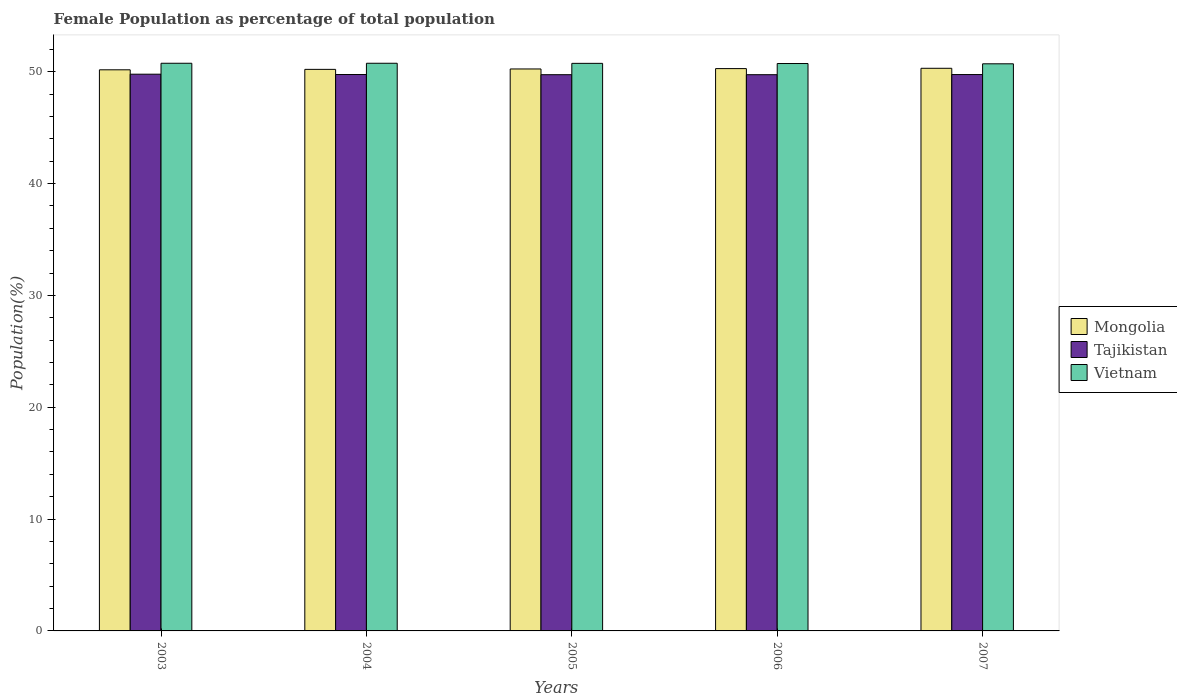How many different coloured bars are there?
Your response must be concise. 3. Are the number of bars on each tick of the X-axis equal?
Offer a terse response. Yes. How many bars are there on the 4th tick from the right?
Provide a short and direct response. 3. What is the label of the 4th group of bars from the left?
Offer a very short reply. 2006. What is the female population in in Vietnam in 2006?
Keep it short and to the point. 50.73. Across all years, what is the maximum female population in in Mongolia?
Ensure brevity in your answer.  50.31. Across all years, what is the minimum female population in in Tajikistan?
Offer a very short reply. 49.74. In which year was the female population in in Vietnam minimum?
Your answer should be compact. 2007. What is the total female population in in Vietnam in the graph?
Provide a short and direct response. 253.71. What is the difference between the female population in in Mongolia in 2004 and that in 2006?
Provide a short and direct response. -0.07. What is the difference between the female population in in Vietnam in 2003 and the female population in in Tajikistan in 2006?
Ensure brevity in your answer.  1.02. What is the average female population in in Mongolia per year?
Your response must be concise. 50.24. In the year 2003, what is the difference between the female population in in Tajikistan and female population in in Mongolia?
Keep it short and to the point. -0.39. What is the ratio of the female population in in Mongolia in 2005 to that in 2006?
Provide a succinct answer. 1. Is the difference between the female population in in Tajikistan in 2004 and 2005 greater than the difference between the female population in in Mongolia in 2004 and 2005?
Offer a terse response. Yes. What is the difference between the highest and the second highest female population in in Vietnam?
Provide a succinct answer. 0. What is the difference between the highest and the lowest female population in in Mongolia?
Your response must be concise. 0.14. Is the sum of the female population in in Tajikistan in 2003 and 2007 greater than the maximum female population in in Mongolia across all years?
Make the answer very short. Yes. What does the 2nd bar from the left in 2005 represents?
Your answer should be very brief. Tajikistan. What does the 2nd bar from the right in 2005 represents?
Offer a terse response. Tajikistan. What is the difference between two consecutive major ticks on the Y-axis?
Your response must be concise. 10. Does the graph contain any zero values?
Offer a terse response. No. Where does the legend appear in the graph?
Your answer should be very brief. Center right. How many legend labels are there?
Your answer should be compact. 3. How are the legend labels stacked?
Ensure brevity in your answer.  Vertical. What is the title of the graph?
Your answer should be compact. Female Population as percentage of total population. What is the label or title of the Y-axis?
Keep it short and to the point. Population(%). What is the Population(%) in Mongolia in 2003?
Offer a very short reply. 50.17. What is the Population(%) in Tajikistan in 2003?
Your response must be concise. 49.78. What is the Population(%) in Vietnam in 2003?
Keep it short and to the point. 50.76. What is the Population(%) of Mongolia in 2004?
Your answer should be compact. 50.21. What is the Population(%) in Tajikistan in 2004?
Provide a succinct answer. 49.75. What is the Population(%) in Vietnam in 2004?
Give a very brief answer. 50.76. What is the Population(%) in Mongolia in 2005?
Keep it short and to the point. 50.25. What is the Population(%) in Tajikistan in 2005?
Give a very brief answer. 49.74. What is the Population(%) in Vietnam in 2005?
Provide a succinct answer. 50.75. What is the Population(%) in Mongolia in 2006?
Keep it short and to the point. 50.28. What is the Population(%) in Tajikistan in 2006?
Provide a succinct answer. 49.74. What is the Population(%) of Vietnam in 2006?
Give a very brief answer. 50.73. What is the Population(%) in Mongolia in 2007?
Your answer should be compact. 50.31. What is the Population(%) in Tajikistan in 2007?
Your answer should be compact. 49.75. What is the Population(%) in Vietnam in 2007?
Give a very brief answer. 50.71. Across all years, what is the maximum Population(%) in Mongolia?
Keep it short and to the point. 50.31. Across all years, what is the maximum Population(%) of Tajikistan?
Ensure brevity in your answer.  49.78. Across all years, what is the maximum Population(%) of Vietnam?
Your response must be concise. 50.76. Across all years, what is the minimum Population(%) in Mongolia?
Your answer should be very brief. 50.17. Across all years, what is the minimum Population(%) in Tajikistan?
Your answer should be compact. 49.74. Across all years, what is the minimum Population(%) in Vietnam?
Keep it short and to the point. 50.71. What is the total Population(%) in Mongolia in the graph?
Offer a very short reply. 251.22. What is the total Population(%) in Tajikistan in the graph?
Your answer should be very brief. 248.75. What is the total Population(%) in Vietnam in the graph?
Make the answer very short. 253.71. What is the difference between the Population(%) of Mongolia in 2003 and that in 2004?
Offer a terse response. -0.04. What is the difference between the Population(%) of Tajikistan in 2003 and that in 2004?
Ensure brevity in your answer.  0.03. What is the difference between the Population(%) of Vietnam in 2003 and that in 2004?
Your answer should be very brief. -0. What is the difference between the Population(%) of Mongolia in 2003 and that in 2005?
Offer a very short reply. -0.08. What is the difference between the Population(%) in Tajikistan in 2003 and that in 2005?
Your answer should be compact. 0.04. What is the difference between the Population(%) of Vietnam in 2003 and that in 2005?
Offer a very short reply. 0.01. What is the difference between the Population(%) in Mongolia in 2003 and that in 2006?
Your answer should be compact. -0.11. What is the difference between the Population(%) in Tajikistan in 2003 and that in 2006?
Give a very brief answer. 0.04. What is the difference between the Population(%) of Vietnam in 2003 and that in 2006?
Your answer should be very brief. 0.02. What is the difference between the Population(%) of Mongolia in 2003 and that in 2007?
Offer a very short reply. -0.14. What is the difference between the Population(%) in Tajikistan in 2003 and that in 2007?
Ensure brevity in your answer.  0.03. What is the difference between the Population(%) of Vietnam in 2003 and that in 2007?
Make the answer very short. 0.05. What is the difference between the Population(%) of Mongolia in 2004 and that in 2005?
Offer a terse response. -0.04. What is the difference between the Population(%) in Tajikistan in 2004 and that in 2005?
Your answer should be very brief. 0.02. What is the difference between the Population(%) of Vietnam in 2004 and that in 2005?
Your response must be concise. 0.01. What is the difference between the Population(%) in Mongolia in 2004 and that in 2006?
Your answer should be compact. -0.07. What is the difference between the Population(%) in Tajikistan in 2004 and that in 2006?
Your answer should be very brief. 0.02. What is the difference between the Population(%) in Vietnam in 2004 and that in 2006?
Offer a very short reply. 0.02. What is the difference between the Population(%) of Mongolia in 2004 and that in 2007?
Your answer should be compact. -0.1. What is the difference between the Population(%) of Tajikistan in 2004 and that in 2007?
Keep it short and to the point. 0. What is the difference between the Population(%) of Vietnam in 2004 and that in 2007?
Provide a succinct answer. 0.05. What is the difference between the Population(%) of Mongolia in 2005 and that in 2006?
Your response must be concise. -0.03. What is the difference between the Population(%) in Tajikistan in 2005 and that in 2006?
Keep it short and to the point. -0. What is the difference between the Population(%) of Vietnam in 2005 and that in 2006?
Make the answer very short. 0.02. What is the difference between the Population(%) of Mongolia in 2005 and that in 2007?
Your answer should be very brief. -0.06. What is the difference between the Population(%) of Tajikistan in 2005 and that in 2007?
Your answer should be very brief. -0.01. What is the difference between the Population(%) in Vietnam in 2005 and that in 2007?
Your answer should be very brief. 0.04. What is the difference between the Population(%) of Mongolia in 2006 and that in 2007?
Make the answer very short. -0.03. What is the difference between the Population(%) in Tajikistan in 2006 and that in 2007?
Offer a very short reply. -0.01. What is the difference between the Population(%) of Vietnam in 2006 and that in 2007?
Make the answer very short. 0.02. What is the difference between the Population(%) in Mongolia in 2003 and the Population(%) in Tajikistan in 2004?
Your response must be concise. 0.42. What is the difference between the Population(%) of Mongolia in 2003 and the Population(%) of Vietnam in 2004?
Your answer should be very brief. -0.59. What is the difference between the Population(%) of Tajikistan in 2003 and the Population(%) of Vietnam in 2004?
Keep it short and to the point. -0.98. What is the difference between the Population(%) in Mongolia in 2003 and the Population(%) in Tajikistan in 2005?
Keep it short and to the point. 0.44. What is the difference between the Population(%) of Mongolia in 2003 and the Population(%) of Vietnam in 2005?
Offer a very short reply. -0.58. What is the difference between the Population(%) of Tajikistan in 2003 and the Population(%) of Vietnam in 2005?
Provide a short and direct response. -0.97. What is the difference between the Population(%) of Mongolia in 2003 and the Population(%) of Tajikistan in 2006?
Your answer should be compact. 0.44. What is the difference between the Population(%) in Mongolia in 2003 and the Population(%) in Vietnam in 2006?
Provide a succinct answer. -0.56. What is the difference between the Population(%) in Tajikistan in 2003 and the Population(%) in Vietnam in 2006?
Provide a succinct answer. -0.95. What is the difference between the Population(%) in Mongolia in 2003 and the Population(%) in Tajikistan in 2007?
Provide a succinct answer. 0.42. What is the difference between the Population(%) of Mongolia in 2003 and the Population(%) of Vietnam in 2007?
Make the answer very short. -0.54. What is the difference between the Population(%) in Tajikistan in 2003 and the Population(%) in Vietnam in 2007?
Give a very brief answer. -0.93. What is the difference between the Population(%) in Mongolia in 2004 and the Population(%) in Tajikistan in 2005?
Ensure brevity in your answer.  0.48. What is the difference between the Population(%) in Mongolia in 2004 and the Population(%) in Vietnam in 2005?
Make the answer very short. -0.54. What is the difference between the Population(%) in Tajikistan in 2004 and the Population(%) in Vietnam in 2005?
Make the answer very short. -1. What is the difference between the Population(%) in Mongolia in 2004 and the Population(%) in Tajikistan in 2006?
Offer a terse response. 0.48. What is the difference between the Population(%) in Mongolia in 2004 and the Population(%) in Vietnam in 2006?
Your response must be concise. -0.52. What is the difference between the Population(%) in Tajikistan in 2004 and the Population(%) in Vietnam in 2006?
Provide a short and direct response. -0.98. What is the difference between the Population(%) in Mongolia in 2004 and the Population(%) in Tajikistan in 2007?
Offer a terse response. 0.46. What is the difference between the Population(%) in Mongolia in 2004 and the Population(%) in Vietnam in 2007?
Give a very brief answer. -0.5. What is the difference between the Population(%) of Tajikistan in 2004 and the Population(%) of Vietnam in 2007?
Ensure brevity in your answer.  -0.96. What is the difference between the Population(%) of Mongolia in 2005 and the Population(%) of Tajikistan in 2006?
Ensure brevity in your answer.  0.51. What is the difference between the Population(%) of Mongolia in 2005 and the Population(%) of Vietnam in 2006?
Your answer should be compact. -0.48. What is the difference between the Population(%) of Tajikistan in 2005 and the Population(%) of Vietnam in 2006?
Your response must be concise. -1. What is the difference between the Population(%) in Mongolia in 2005 and the Population(%) in Tajikistan in 2007?
Keep it short and to the point. 0.5. What is the difference between the Population(%) of Mongolia in 2005 and the Population(%) of Vietnam in 2007?
Make the answer very short. -0.46. What is the difference between the Population(%) in Tajikistan in 2005 and the Population(%) in Vietnam in 2007?
Your answer should be very brief. -0.97. What is the difference between the Population(%) in Mongolia in 2006 and the Population(%) in Tajikistan in 2007?
Provide a succinct answer. 0.53. What is the difference between the Population(%) in Mongolia in 2006 and the Population(%) in Vietnam in 2007?
Offer a very short reply. -0.43. What is the difference between the Population(%) in Tajikistan in 2006 and the Population(%) in Vietnam in 2007?
Make the answer very short. -0.97. What is the average Population(%) of Mongolia per year?
Offer a very short reply. 50.24. What is the average Population(%) in Tajikistan per year?
Provide a short and direct response. 49.75. What is the average Population(%) of Vietnam per year?
Keep it short and to the point. 50.74. In the year 2003, what is the difference between the Population(%) in Mongolia and Population(%) in Tajikistan?
Provide a short and direct response. 0.39. In the year 2003, what is the difference between the Population(%) of Mongolia and Population(%) of Vietnam?
Ensure brevity in your answer.  -0.58. In the year 2003, what is the difference between the Population(%) in Tajikistan and Population(%) in Vietnam?
Make the answer very short. -0.98. In the year 2004, what is the difference between the Population(%) of Mongolia and Population(%) of Tajikistan?
Offer a terse response. 0.46. In the year 2004, what is the difference between the Population(%) in Mongolia and Population(%) in Vietnam?
Offer a terse response. -0.55. In the year 2004, what is the difference between the Population(%) of Tajikistan and Population(%) of Vietnam?
Offer a very short reply. -1.01. In the year 2005, what is the difference between the Population(%) of Mongolia and Population(%) of Tajikistan?
Provide a succinct answer. 0.51. In the year 2005, what is the difference between the Population(%) in Mongolia and Population(%) in Vietnam?
Ensure brevity in your answer.  -0.5. In the year 2005, what is the difference between the Population(%) of Tajikistan and Population(%) of Vietnam?
Keep it short and to the point. -1.02. In the year 2006, what is the difference between the Population(%) of Mongolia and Population(%) of Tajikistan?
Offer a terse response. 0.54. In the year 2006, what is the difference between the Population(%) in Mongolia and Population(%) in Vietnam?
Make the answer very short. -0.45. In the year 2006, what is the difference between the Population(%) in Tajikistan and Population(%) in Vietnam?
Offer a very short reply. -1. In the year 2007, what is the difference between the Population(%) in Mongolia and Population(%) in Tajikistan?
Offer a very short reply. 0.56. In the year 2007, what is the difference between the Population(%) in Mongolia and Population(%) in Vietnam?
Give a very brief answer. -0.4. In the year 2007, what is the difference between the Population(%) in Tajikistan and Population(%) in Vietnam?
Offer a very short reply. -0.96. What is the ratio of the Population(%) of Vietnam in 2003 to that in 2005?
Provide a succinct answer. 1. What is the ratio of the Population(%) in Mongolia in 2003 to that in 2006?
Ensure brevity in your answer.  1. What is the ratio of the Population(%) in Mongolia in 2003 to that in 2007?
Keep it short and to the point. 1. What is the ratio of the Population(%) of Mongolia in 2004 to that in 2005?
Keep it short and to the point. 1. What is the ratio of the Population(%) in Mongolia in 2004 to that in 2006?
Your answer should be compact. 1. What is the ratio of the Population(%) in Tajikistan in 2004 to that in 2006?
Offer a terse response. 1. What is the ratio of the Population(%) of Vietnam in 2004 to that in 2006?
Your response must be concise. 1. What is the ratio of the Population(%) in Mongolia in 2004 to that in 2007?
Provide a succinct answer. 1. What is the ratio of the Population(%) of Tajikistan in 2005 to that in 2006?
Give a very brief answer. 1. What is the ratio of the Population(%) of Mongolia in 2006 to that in 2007?
Your response must be concise. 1. What is the ratio of the Population(%) in Tajikistan in 2006 to that in 2007?
Make the answer very short. 1. What is the difference between the highest and the second highest Population(%) of Mongolia?
Your response must be concise. 0.03. What is the difference between the highest and the second highest Population(%) in Tajikistan?
Your answer should be very brief. 0.03. What is the difference between the highest and the lowest Population(%) in Mongolia?
Provide a short and direct response. 0.14. What is the difference between the highest and the lowest Population(%) of Tajikistan?
Make the answer very short. 0.04. What is the difference between the highest and the lowest Population(%) in Vietnam?
Your answer should be very brief. 0.05. 